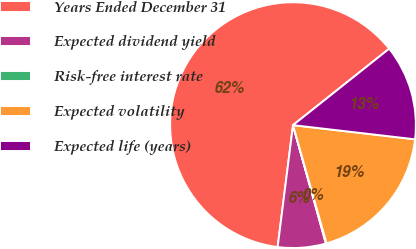<chart> <loc_0><loc_0><loc_500><loc_500><pie_chart><fcel>Years Ended December 31<fcel>Expected dividend yield<fcel>Risk-free interest rate<fcel>Expected volatility<fcel>Expected life (years)<nl><fcel>62.32%<fcel>6.31%<fcel>0.09%<fcel>18.76%<fcel>12.53%<nl></chart> 